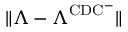<formula> <loc_0><loc_0><loc_500><loc_500>\| \Lambda - \Lambda ^ { C D C ^ { - } } \|</formula> 